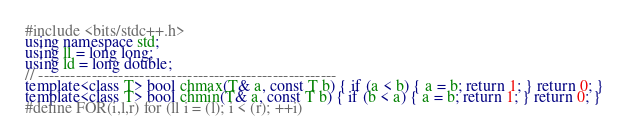Convert code to text. <code><loc_0><loc_0><loc_500><loc_500><_C++_>#include <bits/stdc++.h>
using namespace std;
using ll = long long;
using ld = long double;
// --------------------------------------------------------
template<class T> bool chmax(T& a, const T b) { if (a < b) { a = b; return 1; } return 0; }
template<class T> bool chmin(T& a, const T b) { if (b < a) { a = b; return 1; } return 0; }
#define FOR(i,l,r) for (ll i = (l); i < (r); ++i)</code> 